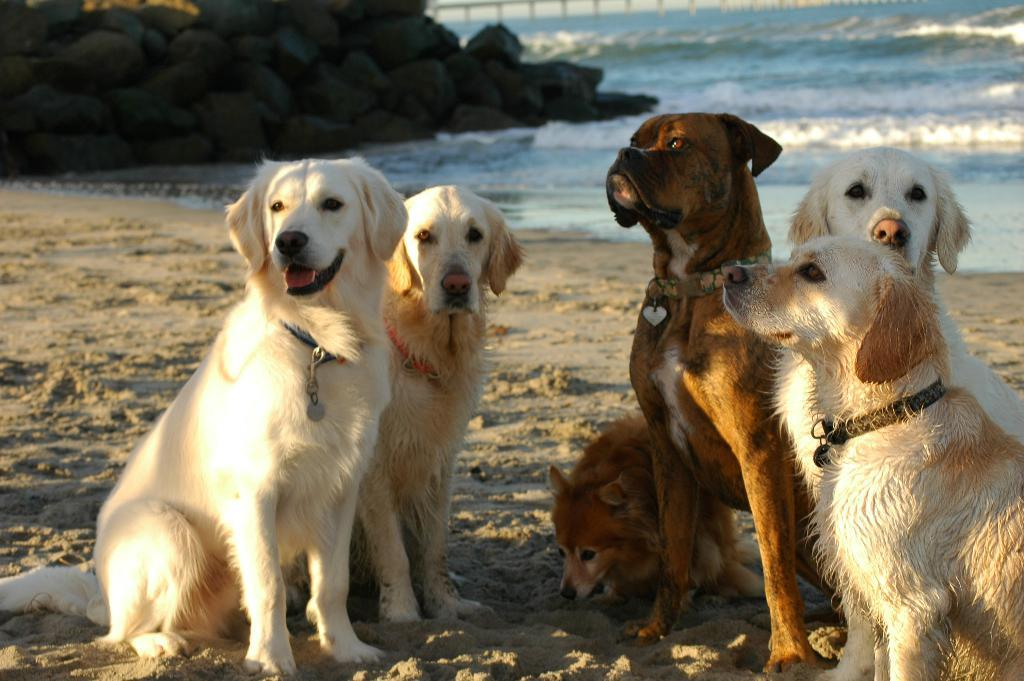How many dogs are present in the image? There are six dogs in the image. Where are the dogs located in the image? The dogs are sitting on the seashore. What are the dogs doing in the image? The dogs are looking at someone. What type of love can be seen between the dogs and the stranger in the image? There is no stranger present in the image, and the dogs are not interacting with any specific person. 